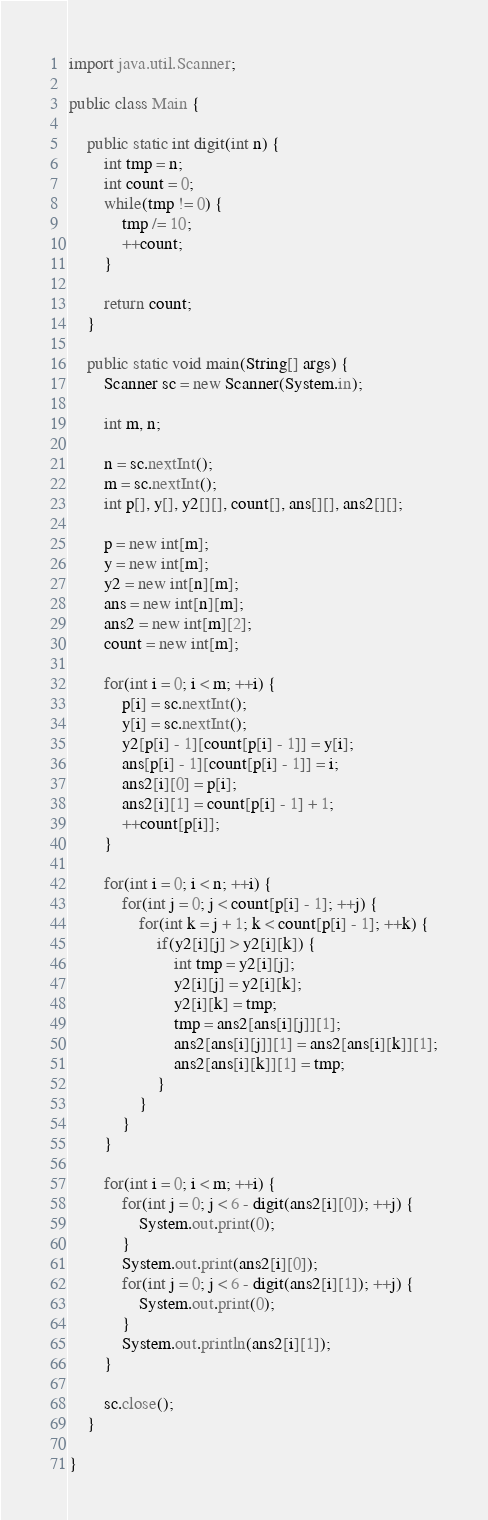<code> <loc_0><loc_0><loc_500><loc_500><_Java_>
import java.util.Scanner;

public class Main {

	public static int digit(int n) {
		int tmp = n;
		int count = 0;
		while(tmp != 0) {
			tmp /= 10;
			++count;
		}
		
		return count;
	}
	
	public static void main(String[] args) {
		Scanner sc = new Scanner(System.in);
		
		int m, n;
		
		n = sc.nextInt();
		m = sc.nextInt();
		int p[], y[], y2[][], count[], ans[][], ans2[][];
		
		p = new int[m];
		y = new int[m];
		y2 = new int[n][m];
		ans = new int[n][m];
		ans2 = new int[m][2];
		count = new int[m];
		
		for(int i = 0; i < m; ++i) {
			p[i] = sc.nextInt();
			y[i] = sc.nextInt();
			y2[p[i] - 1][count[p[i] - 1]] = y[i];
			ans[p[i] - 1][count[p[i] - 1]] = i;
			ans2[i][0] = p[i];
			ans2[i][1] = count[p[i] - 1] + 1;
			++count[p[i]];
		}
		
		for(int i = 0; i < n; ++i) {
			for(int j = 0; j < count[p[i] - 1]; ++j) {
				for(int k = j + 1; k < count[p[i] - 1]; ++k) {
					if(y2[i][j] > y2[i][k]) {
						int tmp = y2[i][j];
						y2[i][j] = y2[i][k];
						y2[i][k] = tmp;
						tmp = ans2[ans[i][j]][1];
						ans2[ans[i][j]][1] = ans2[ans[i][k]][1];
						ans2[ans[i][k]][1] = tmp;
					}
				}
			}
		}
		
		for(int i = 0; i < m; ++i) {
			for(int j = 0; j < 6 - digit(ans2[i][0]); ++j) {
				System.out.print(0);
			}
			System.out.print(ans2[i][0]);
			for(int j = 0; j < 6 - digit(ans2[i][1]); ++j) {
				System.out.print(0);
			}
			System.out.println(ans2[i][1]);
		}
		
		sc.close();
	}

}
</code> 